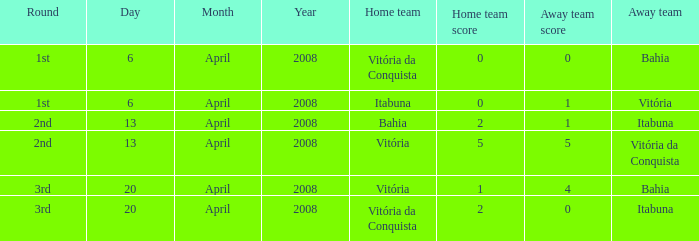What is the name of the home team on April 13, 2008 when Itabuna was the away team? Bahia. 